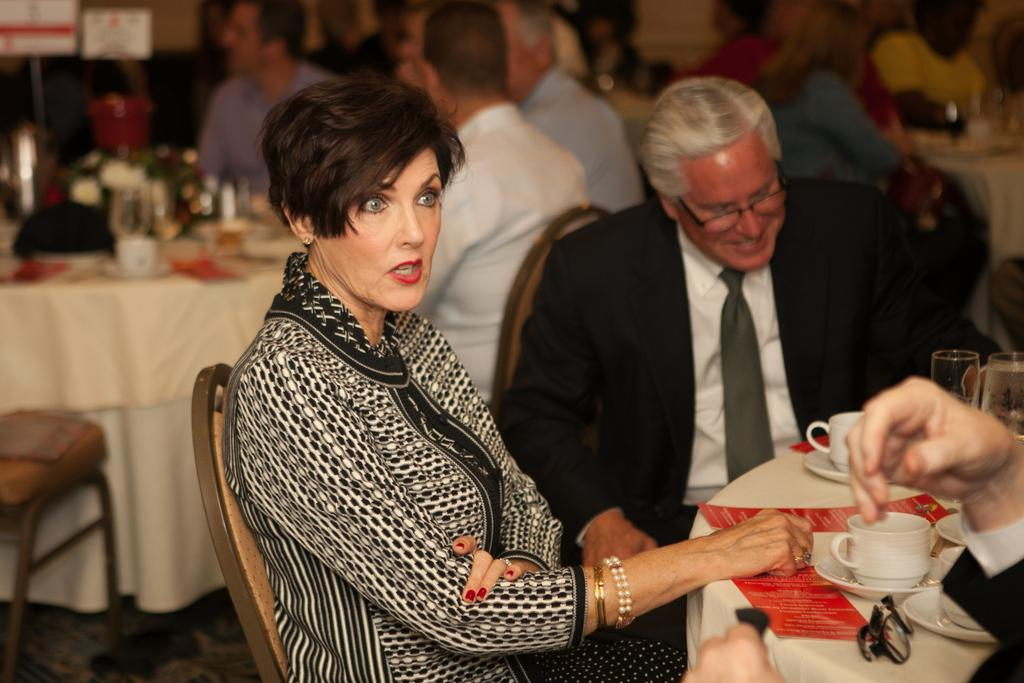What is the woman doing in the image? The woman is sitting on a chair in the image. How is the man dressed in the image? The man is wearing a tie, shirt, and coat in the image. Where is the man positioned in relation to the woman? The man is beside the woman in the image. What objects can be seen on the table in the image? There are tea cups on a table in the image. What type of leather is covering the flag in the image? There is no flag or leather present in the image. 